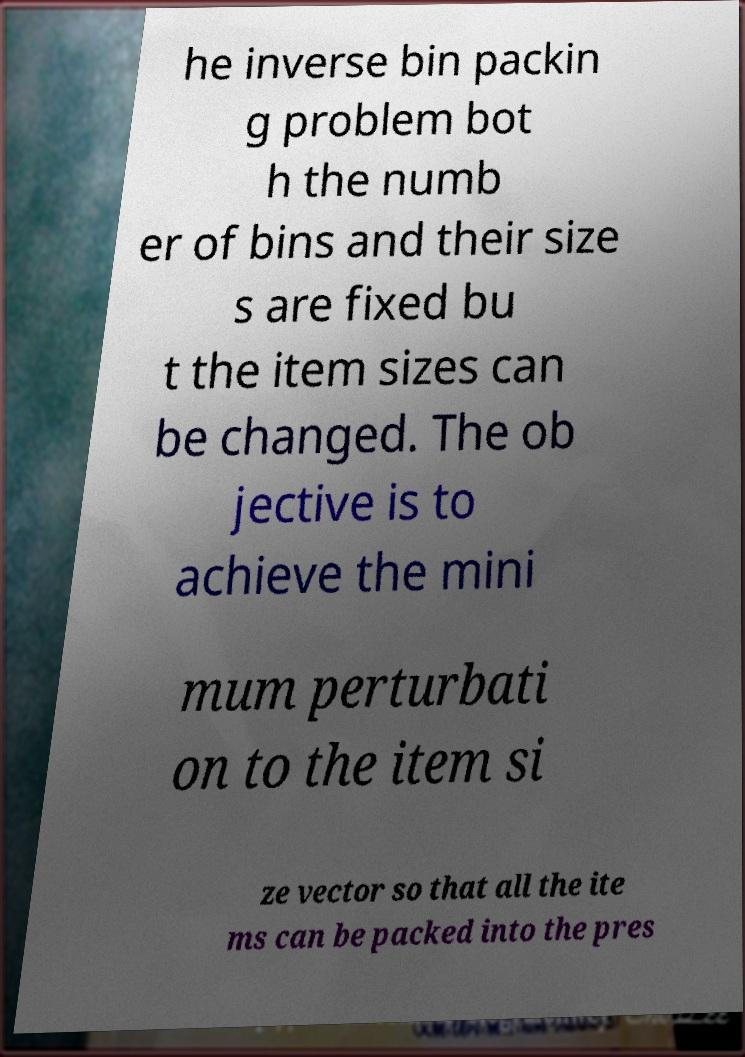Please read and relay the text visible in this image. What does it say? he inverse bin packin g problem bot h the numb er of bins and their size s are fixed bu t the item sizes can be changed. The ob jective is to achieve the mini mum perturbati on to the item si ze vector so that all the ite ms can be packed into the pres 